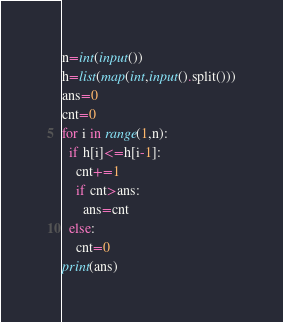Convert code to text. <code><loc_0><loc_0><loc_500><loc_500><_Python_>n=int(input())
h=list(map(int,input().split()))
ans=0
cnt=0
for i in range(1,n):
  if h[i]<=h[i-1]:
    cnt+=1
    if cnt>ans:
      ans=cnt
  else:
    cnt=0
print(ans)</code> 